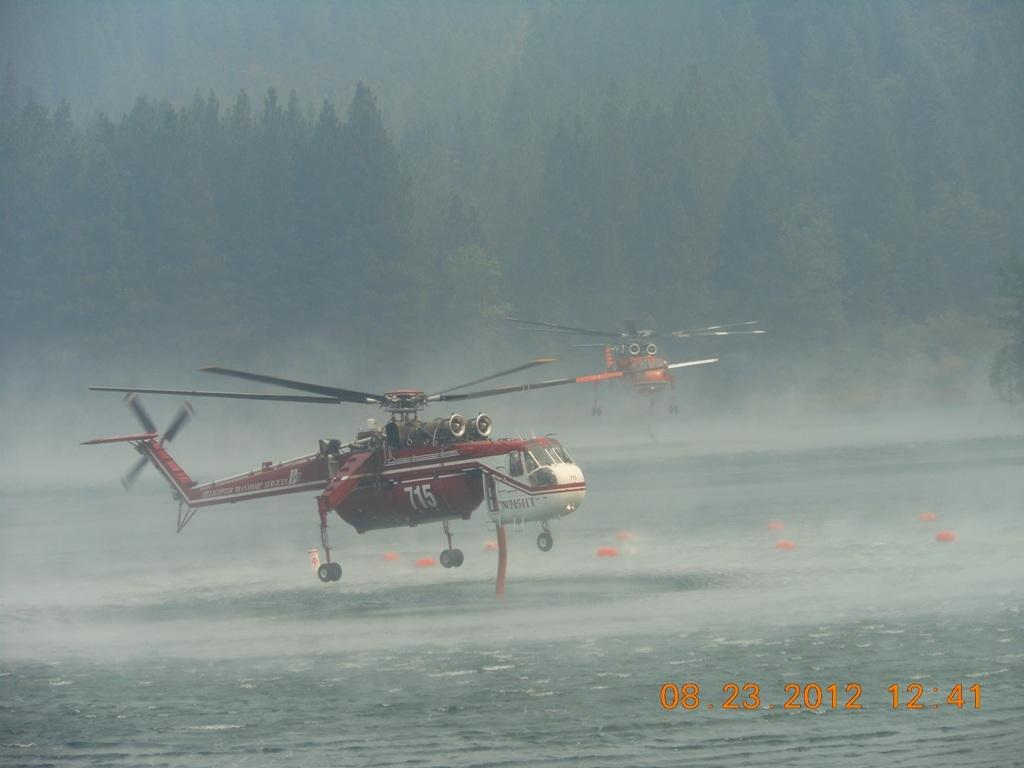How many helicopters can be seen in the image? There are two helicopters in the image. What are the helicopters doing in the image? The helicopters are flying in the air. Where are the helicopters located in the image? The helicopters are above a sea. What other natural elements can be seen in the image? There are trees visible in the image. What type of letter is being delivered by the helicopters in the image? There is no letter being delivered by the helicopters in the image; they are simply flying above a sea. 